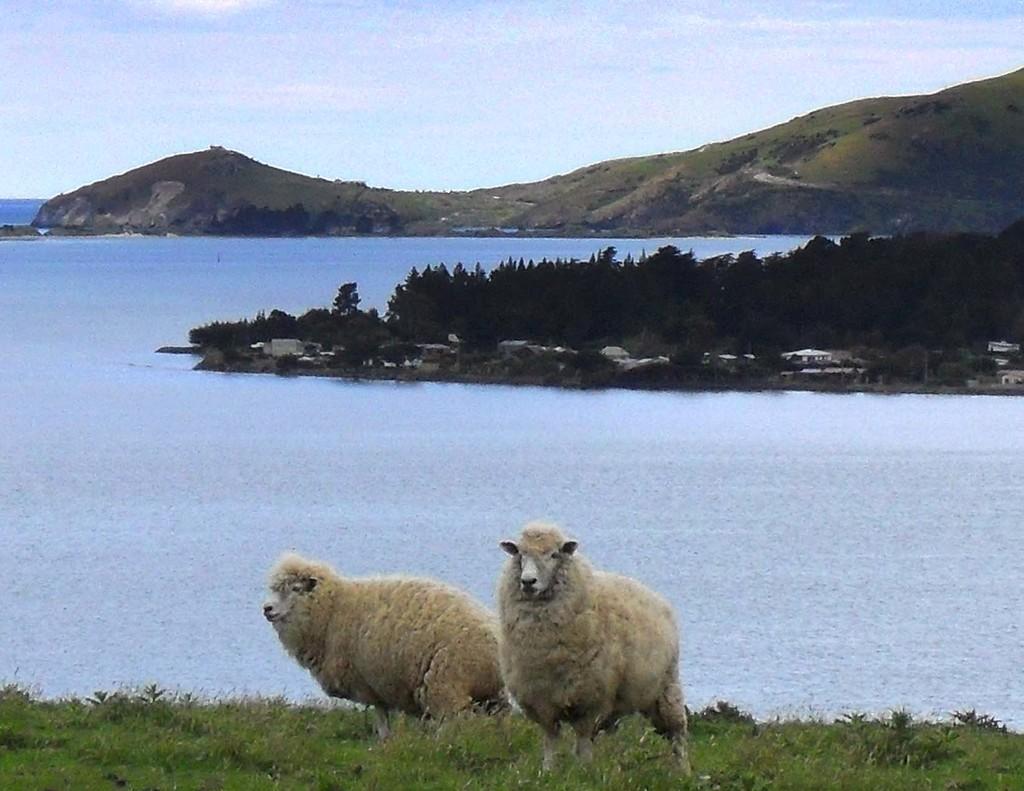Describe this image in one or two sentences. In this image I can see the ground, some grass on the ground and two sheep which are cream and white in color. In the background I can see the water, few trees, few buildings, few mountains and the sky. 